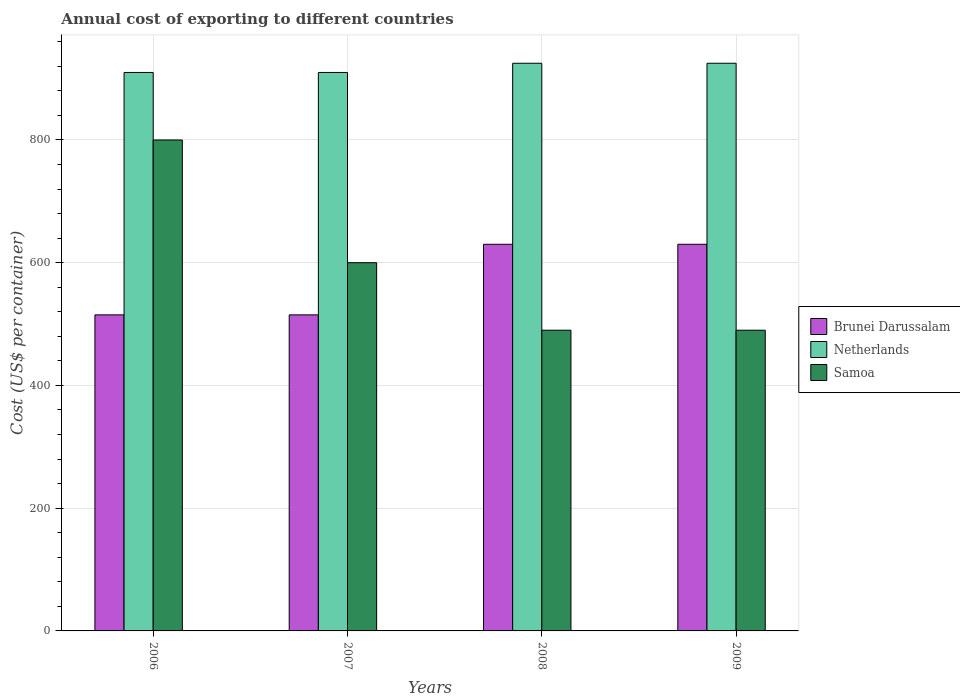How many different coloured bars are there?
Provide a succinct answer. 3. How many groups of bars are there?
Your answer should be very brief. 4. Are the number of bars on each tick of the X-axis equal?
Offer a very short reply. Yes. How many bars are there on the 2nd tick from the left?
Make the answer very short. 3. What is the label of the 4th group of bars from the left?
Offer a terse response. 2009. What is the total annual cost of exporting in Netherlands in 2007?
Your response must be concise. 910. Across all years, what is the maximum total annual cost of exporting in Samoa?
Provide a succinct answer. 800. Across all years, what is the minimum total annual cost of exporting in Netherlands?
Offer a very short reply. 910. In which year was the total annual cost of exporting in Brunei Darussalam maximum?
Give a very brief answer. 2008. What is the total total annual cost of exporting in Brunei Darussalam in the graph?
Your answer should be compact. 2290. What is the difference between the total annual cost of exporting in Netherlands in 2007 and that in 2009?
Make the answer very short. -15. What is the difference between the total annual cost of exporting in Brunei Darussalam in 2008 and the total annual cost of exporting in Netherlands in 2009?
Provide a succinct answer. -295. What is the average total annual cost of exporting in Netherlands per year?
Keep it short and to the point. 917.5. In the year 2007, what is the difference between the total annual cost of exporting in Samoa and total annual cost of exporting in Netherlands?
Make the answer very short. -310. What is the ratio of the total annual cost of exporting in Samoa in 2006 to that in 2008?
Offer a very short reply. 1.63. Is the difference between the total annual cost of exporting in Samoa in 2007 and 2009 greater than the difference between the total annual cost of exporting in Netherlands in 2007 and 2009?
Provide a succinct answer. Yes. What is the difference between the highest and the lowest total annual cost of exporting in Samoa?
Your answer should be compact. 310. In how many years, is the total annual cost of exporting in Netherlands greater than the average total annual cost of exporting in Netherlands taken over all years?
Ensure brevity in your answer.  2. Is the sum of the total annual cost of exporting in Brunei Darussalam in 2006 and 2008 greater than the maximum total annual cost of exporting in Netherlands across all years?
Offer a very short reply. Yes. What does the 3rd bar from the right in 2009 represents?
Offer a very short reply. Brunei Darussalam. How many years are there in the graph?
Give a very brief answer. 4. Are the values on the major ticks of Y-axis written in scientific E-notation?
Keep it short and to the point. No. Does the graph contain any zero values?
Offer a terse response. No. Where does the legend appear in the graph?
Offer a very short reply. Center right. How many legend labels are there?
Your answer should be compact. 3. How are the legend labels stacked?
Provide a succinct answer. Vertical. What is the title of the graph?
Your answer should be compact. Annual cost of exporting to different countries. What is the label or title of the Y-axis?
Ensure brevity in your answer.  Cost (US$ per container). What is the Cost (US$ per container) of Brunei Darussalam in 2006?
Offer a very short reply. 515. What is the Cost (US$ per container) of Netherlands in 2006?
Give a very brief answer. 910. What is the Cost (US$ per container) of Samoa in 2006?
Your response must be concise. 800. What is the Cost (US$ per container) of Brunei Darussalam in 2007?
Offer a terse response. 515. What is the Cost (US$ per container) of Netherlands in 2007?
Keep it short and to the point. 910. What is the Cost (US$ per container) in Samoa in 2007?
Offer a terse response. 600. What is the Cost (US$ per container) in Brunei Darussalam in 2008?
Your answer should be compact. 630. What is the Cost (US$ per container) in Netherlands in 2008?
Provide a short and direct response. 925. What is the Cost (US$ per container) in Samoa in 2008?
Keep it short and to the point. 490. What is the Cost (US$ per container) in Brunei Darussalam in 2009?
Keep it short and to the point. 630. What is the Cost (US$ per container) of Netherlands in 2009?
Keep it short and to the point. 925. What is the Cost (US$ per container) of Samoa in 2009?
Your answer should be very brief. 490. Across all years, what is the maximum Cost (US$ per container) in Brunei Darussalam?
Provide a short and direct response. 630. Across all years, what is the maximum Cost (US$ per container) of Netherlands?
Your answer should be very brief. 925. Across all years, what is the maximum Cost (US$ per container) in Samoa?
Give a very brief answer. 800. Across all years, what is the minimum Cost (US$ per container) of Brunei Darussalam?
Provide a short and direct response. 515. Across all years, what is the minimum Cost (US$ per container) in Netherlands?
Your response must be concise. 910. Across all years, what is the minimum Cost (US$ per container) of Samoa?
Give a very brief answer. 490. What is the total Cost (US$ per container) of Brunei Darussalam in the graph?
Your answer should be compact. 2290. What is the total Cost (US$ per container) in Netherlands in the graph?
Your answer should be very brief. 3670. What is the total Cost (US$ per container) of Samoa in the graph?
Your answer should be compact. 2380. What is the difference between the Cost (US$ per container) of Netherlands in 2006 and that in 2007?
Provide a short and direct response. 0. What is the difference between the Cost (US$ per container) in Brunei Darussalam in 2006 and that in 2008?
Give a very brief answer. -115. What is the difference between the Cost (US$ per container) of Netherlands in 2006 and that in 2008?
Give a very brief answer. -15. What is the difference between the Cost (US$ per container) of Samoa in 2006 and that in 2008?
Your answer should be very brief. 310. What is the difference between the Cost (US$ per container) in Brunei Darussalam in 2006 and that in 2009?
Make the answer very short. -115. What is the difference between the Cost (US$ per container) in Netherlands in 2006 and that in 2009?
Provide a short and direct response. -15. What is the difference between the Cost (US$ per container) in Samoa in 2006 and that in 2009?
Offer a terse response. 310. What is the difference between the Cost (US$ per container) of Brunei Darussalam in 2007 and that in 2008?
Your answer should be very brief. -115. What is the difference between the Cost (US$ per container) of Samoa in 2007 and that in 2008?
Your response must be concise. 110. What is the difference between the Cost (US$ per container) in Brunei Darussalam in 2007 and that in 2009?
Offer a very short reply. -115. What is the difference between the Cost (US$ per container) in Samoa in 2007 and that in 2009?
Offer a terse response. 110. What is the difference between the Cost (US$ per container) in Netherlands in 2008 and that in 2009?
Your response must be concise. 0. What is the difference between the Cost (US$ per container) in Samoa in 2008 and that in 2009?
Your answer should be very brief. 0. What is the difference between the Cost (US$ per container) of Brunei Darussalam in 2006 and the Cost (US$ per container) of Netherlands in 2007?
Your answer should be very brief. -395. What is the difference between the Cost (US$ per container) of Brunei Darussalam in 2006 and the Cost (US$ per container) of Samoa in 2007?
Your answer should be very brief. -85. What is the difference between the Cost (US$ per container) in Netherlands in 2006 and the Cost (US$ per container) in Samoa in 2007?
Keep it short and to the point. 310. What is the difference between the Cost (US$ per container) in Brunei Darussalam in 2006 and the Cost (US$ per container) in Netherlands in 2008?
Your answer should be compact. -410. What is the difference between the Cost (US$ per container) in Netherlands in 2006 and the Cost (US$ per container) in Samoa in 2008?
Your answer should be very brief. 420. What is the difference between the Cost (US$ per container) in Brunei Darussalam in 2006 and the Cost (US$ per container) in Netherlands in 2009?
Your response must be concise. -410. What is the difference between the Cost (US$ per container) in Brunei Darussalam in 2006 and the Cost (US$ per container) in Samoa in 2009?
Your answer should be compact. 25. What is the difference between the Cost (US$ per container) in Netherlands in 2006 and the Cost (US$ per container) in Samoa in 2009?
Offer a very short reply. 420. What is the difference between the Cost (US$ per container) of Brunei Darussalam in 2007 and the Cost (US$ per container) of Netherlands in 2008?
Offer a very short reply. -410. What is the difference between the Cost (US$ per container) in Netherlands in 2007 and the Cost (US$ per container) in Samoa in 2008?
Ensure brevity in your answer.  420. What is the difference between the Cost (US$ per container) in Brunei Darussalam in 2007 and the Cost (US$ per container) in Netherlands in 2009?
Your answer should be very brief. -410. What is the difference between the Cost (US$ per container) in Netherlands in 2007 and the Cost (US$ per container) in Samoa in 2009?
Provide a short and direct response. 420. What is the difference between the Cost (US$ per container) of Brunei Darussalam in 2008 and the Cost (US$ per container) of Netherlands in 2009?
Offer a terse response. -295. What is the difference between the Cost (US$ per container) of Brunei Darussalam in 2008 and the Cost (US$ per container) of Samoa in 2009?
Give a very brief answer. 140. What is the difference between the Cost (US$ per container) in Netherlands in 2008 and the Cost (US$ per container) in Samoa in 2009?
Your answer should be very brief. 435. What is the average Cost (US$ per container) in Brunei Darussalam per year?
Offer a terse response. 572.5. What is the average Cost (US$ per container) in Netherlands per year?
Keep it short and to the point. 917.5. What is the average Cost (US$ per container) in Samoa per year?
Offer a very short reply. 595. In the year 2006, what is the difference between the Cost (US$ per container) of Brunei Darussalam and Cost (US$ per container) of Netherlands?
Provide a succinct answer. -395. In the year 2006, what is the difference between the Cost (US$ per container) in Brunei Darussalam and Cost (US$ per container) in Samoa?
Your answer should be very brief. -285. In the year 2006, what is the difference between the Cost (US$ per container) of Netherlands and Cost (US$ per container) of Samoa?
Offer a very short reply. 110. In the year 2007, what is the difference between the Cost (US$ per container) in Brunei Darussalam and Cost (US$ per container) in Netherlands?
Make the answer very short. -395. In the year 2007, what is the difference between the Cost (US$ per container) in Brunei Darussalam and Cost (US$ per container) in Samoa?
Offer a terse response. -85. In the year 2007, what is the difference between the Cost (US$ per container) of Netherlands and Cost (US$ per container) of Samoa?
Your answer should be compact. 310. In the year 2008, what is the difference between the Cost (US$ per container) of Brunei Darussalam and Cost (US$ per container) of Netherlands?
Your answer should be compact. -295. In the year 2008, what is the difference between the Cost (US$ per container) of Brunei Darussalam and Cost (US$ per container) of Samoa?
Your answer should be very brief. 140. In the year 2008, what is the difference between the Cost (US$ per container) in Netherlands and Cost (US$ per container) in Samoa?
Provide a succinct answer. 435. In the year 2009, what is the difference between the Cost (US$ per container) in Brunei Darussalam and Cost (US$ per container) in Netherlands?
Ensure brevity in your answer.  -295. In the year 2009, what is the difference between the Cost (US$ per container) in Brunei Darussalam and Cost (US$ per container) in Samoa?
Ensure brevity in your answer.  140. In the year 2009, what is the difference between the Cost (US$ per container) of Netherlands and Cost (US$ per container) of Samoa?
Offer a very short reply. 435. What is the ratio of the Cost (US$ per container) in Brunei Darussalam in 2006 to that in 2007?
Offer a terse response. 1. What is the ratio of the Cost (US$ per container) in Brunei Darussalam in 2006 to that in 2008?
Offer a terse response. 0.82. What is the ratio of the Cost (US$ per container) of Netherlands in 2006 to that in 2008?
Offer a terse response. 0.98. What is the ratio of the Cost (US$ per container) in Samoa in 2006 to that in 2008?
Provide a short and direct response. 1.63. What is the ratio of the Cost (US$ per container) of Brunei Darussalam in 2006 to that in 2009?
Provide a succinct answer. 0.82. What is the ratio of the Cost (US$ per container) of Netherlands in 2006 to that in 2009?
Your answer should be compact. 0.98. What is the ratio of the Cost (US$ per container) in Samoa in 2006 to that in 2009?
Offer a very short reply. 1.63. What is the ratio of the Cost (US$ per container) in Brunei Darussalam in 2007 to that in 2008?
Give a very brief answer. 0.82. What is the ratio of the Cost (US$ per container) in Netherlands in 2007 to that in 2008?
Your response must be concise. 0.98. What is the ratio of the Cost (US$ per container) of Samoa in 2007 to that in 2008?
Ensure brevity in your answer.  1.22. What is the ratio of the Cost (US$ per container) in Brunei Darussalam in 2007 to that in 2009?
Your answer should be compact. 0.82. What is the ratio of the Cost (US$ per container) in Netherlands in 2007 to that in 2009?
Provide a succinct answer. 0.98. What is the ratio of the Cost (US$ per container) of Samoa in 2007 to that in 2009?
Give a very brief answer. 1.22. What is the ratio of the Cost (US$ per container) in Samoa in 2008 to that in 2009?
Your answer should be compact. 1. What is the difference between the highest and the second highest Cost (US$ per container) in Brunei Darussalam?
Provide a short and direct response. 0. What is the difference between the highest and the second highest Cost (US$ per container) of Samoa?
Your response must be concise. 200. What is the difference between the highest and the lowest Cost (US$ per container) of Brunei Darussalam?
Your response must be concise. 115. What is the difference between the highest and the lowest Cost (US$ per container) of Samoa?
Keep it short and to the point. 310. 